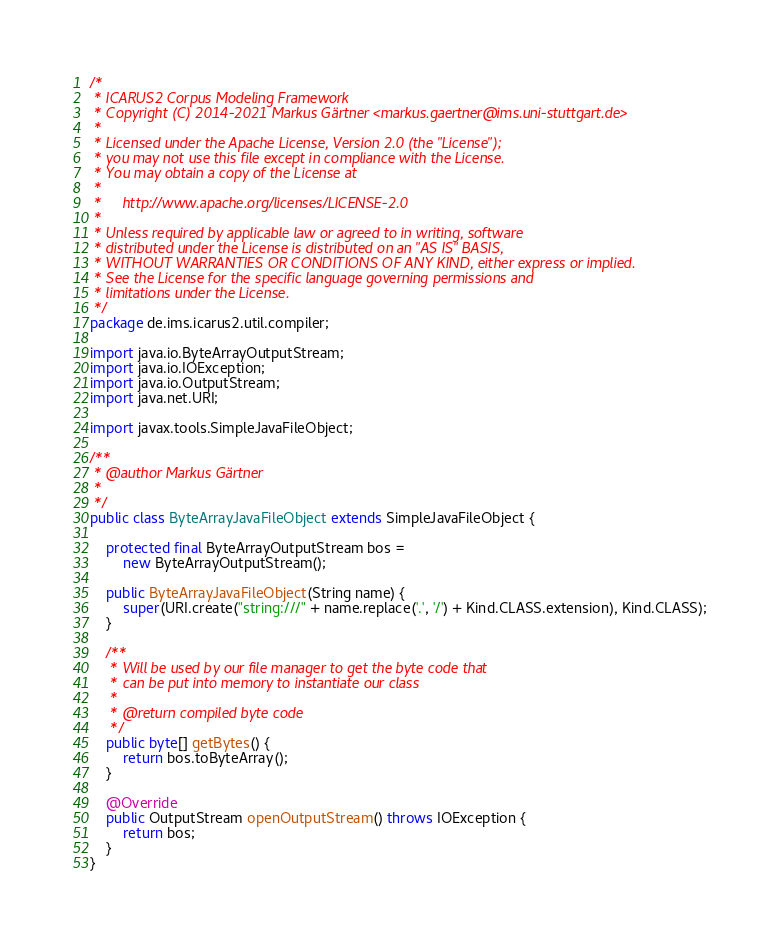<code> <loc_0><loc_0><loc_500><loc_500><_Java_>/*
 * ICARUS2 Corpus Modeling Framework
 * Copyright (C) 2014-2021 Markus Gärtner <markus.gaertner@ims.uni-stuttgart.de>
 *
 * Licensed under the Apache License, Version 2.0 (the "License");
 * you may not use this file except in compliance with the License.
 * You may obtain a copy of the License at
 *
 *     http://www.apache.org/licenses/LICENSE-2.0
 *
 * Unless required by applicable law or agreed to in writing, software
 * distributed under the License is distributed on an "AS IS" BASIS,
 * WITHOUT WARRANTIES OR CONDITIONS OF ANY KIND, either express or implied.
 * See the License for the specific language governing permissions and
 * limitations under the License.
 */
package de.ims.icarus2.util.compiler;

import java.io.ByteArrayOutputStream;
import java.io.IOException;
import java.io.OutputStream;
import java.net.URI;

import javax.tools.SimpleJavaFileObject;

/**
 * @author Markus Gärtner
 *
 */
public class ByteArrayJavaFileObject extends SimpleJavaFileObject {

    protected final ByteArrayOutputStream bos =
        new ByteArrayOutputStream();

    public ByteArrayJavaFileObject(String name) {
        super(URI.create("string:///" + name.replace('.', '/') + Kind.CLASS.extension), Kind.CLASS);
    }

    /**
     * Will be used by our file manager to get the byte code that
     * can be put into memory to instantiate our class
     *
     * @return compiled byte code
     */
    public byte[] getBytes() {
        return bos.toByteArray();
    }

    @Override
    public OutputStream openOutputStream() throws IOException {
        return bos;
    }
}</code> 